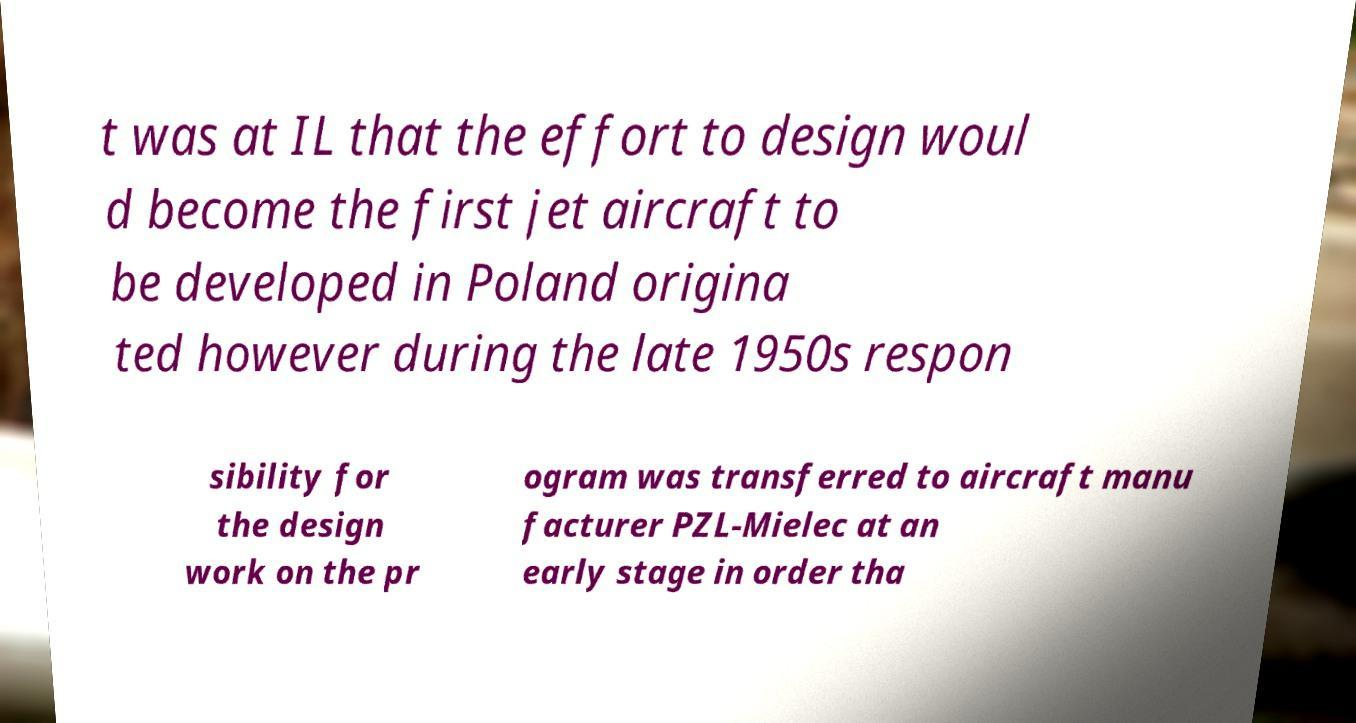There's text embedded in this image that I need extracted. Can you transcribe it verbatim? t was at IL that the effort to design woul d become the first jet aircraft to be developed in Poland origina ted however during the late 1950s respon sibility for the design work on the pr ogram was transferred to aircraft manu facturer PZL-Mielec at an early stage in order tha 